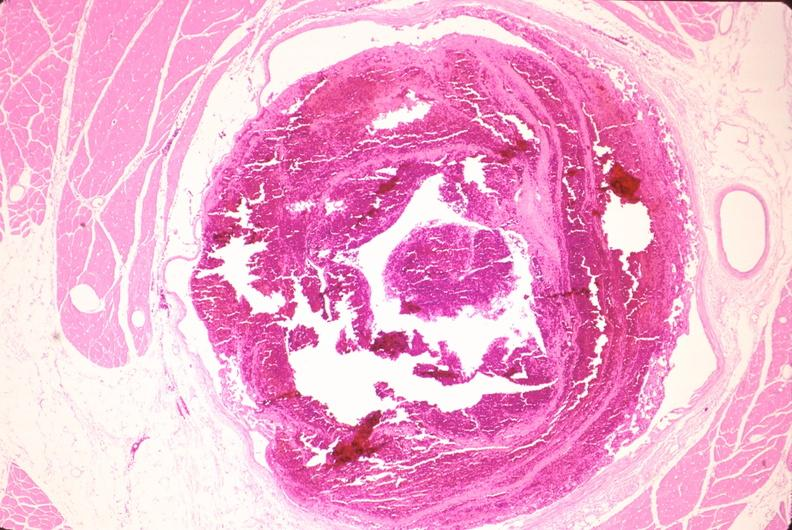s cardiovascular present?
Answer the question using a single word or phrase. Yes 